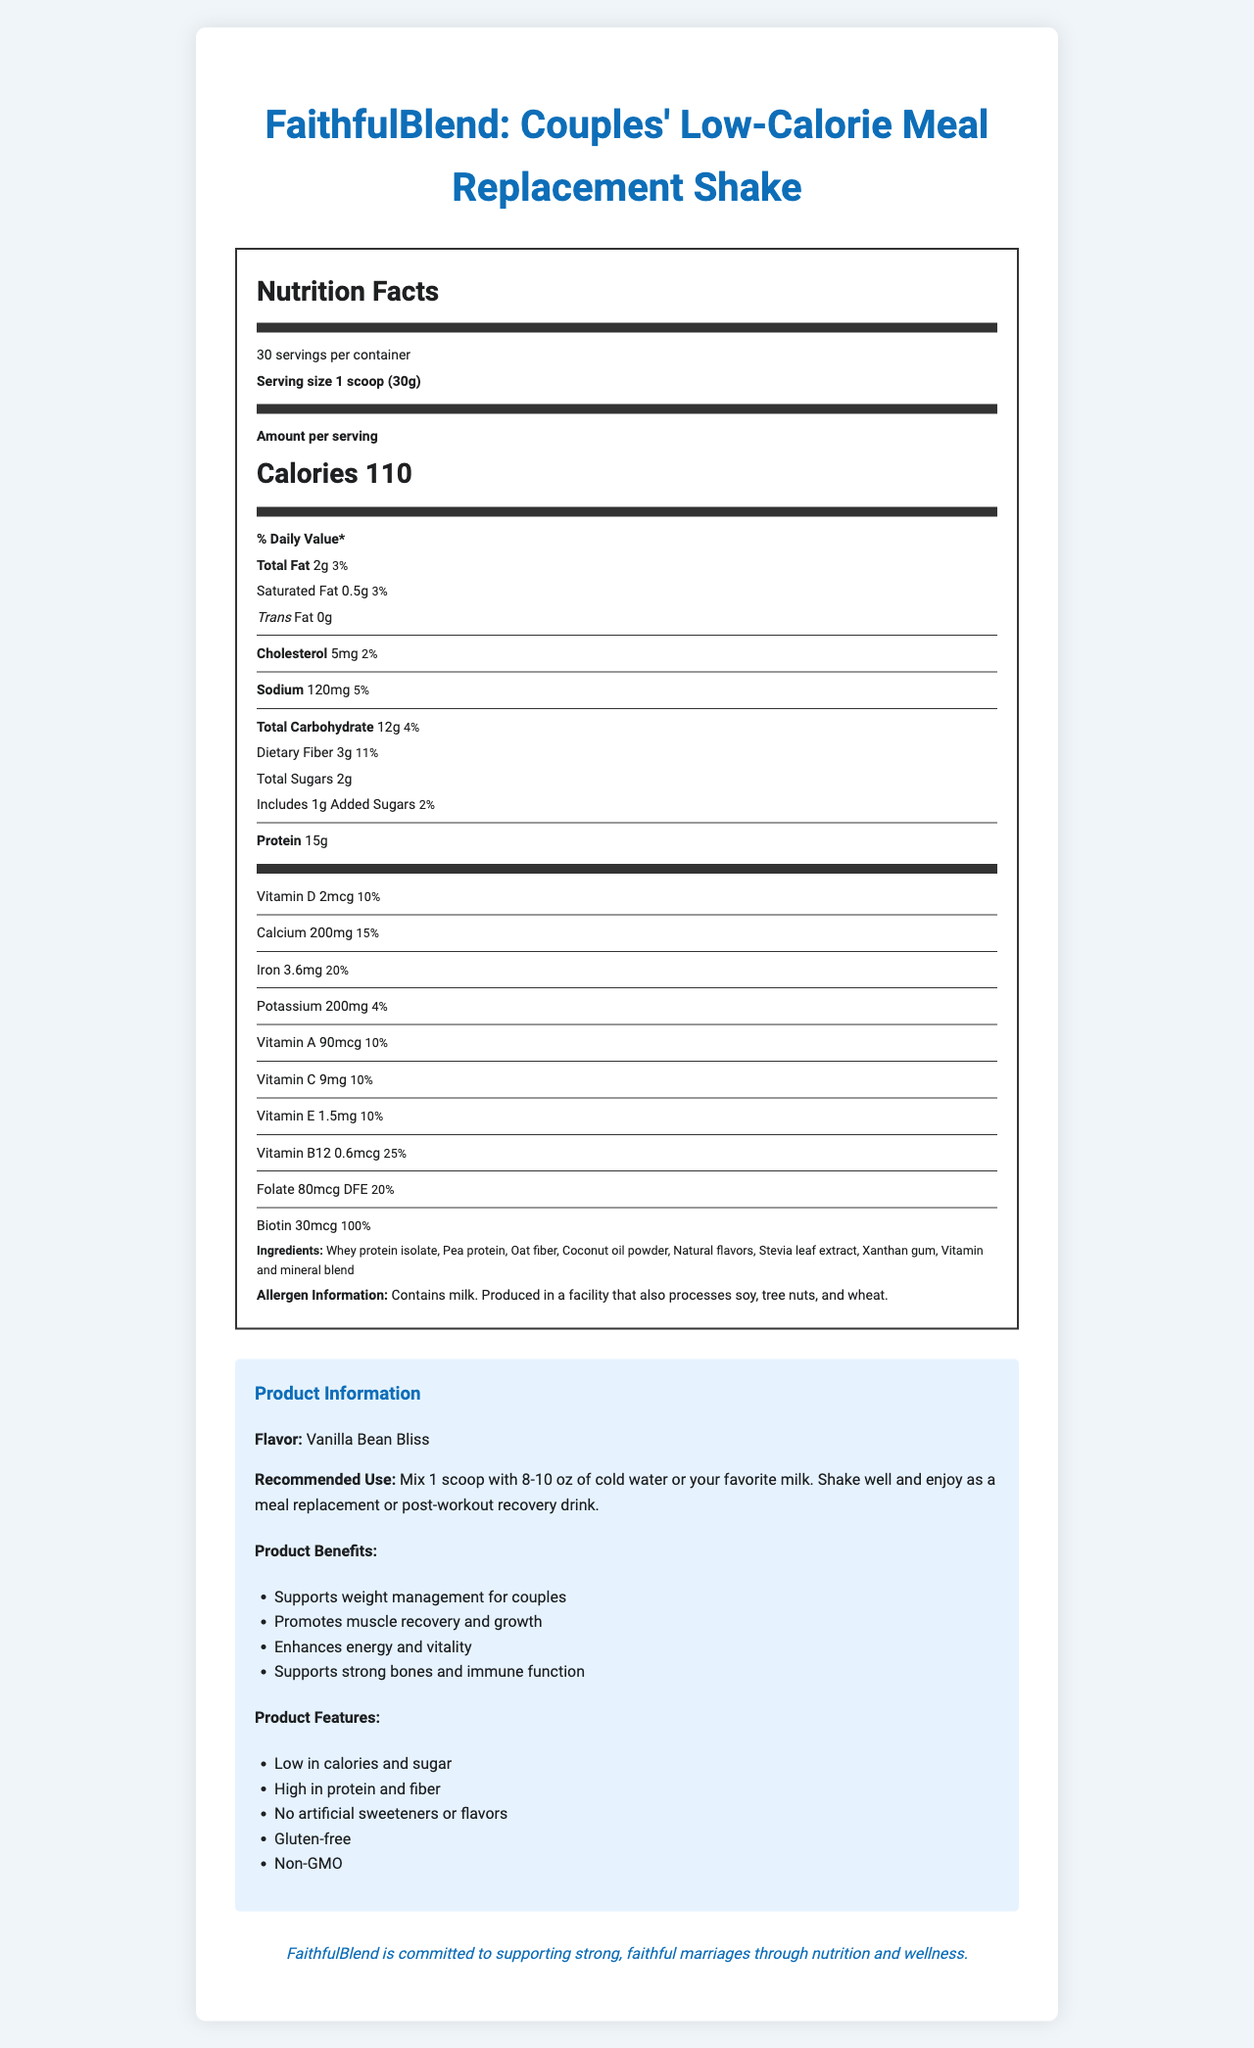what is the serving size for this meal replacement shake? The document states that the serving size is 1 scoop which weighs 30 grams.
Answer: 1 scoop (30g) how many servings are in one container? The document indicates that there are 30 servings per container.
Answer: 30 servings how many calories are in one serving of this shake? The calorie count per serving is listed as 110.
Answer: 110 calories what is the amount of protein in one serving? The amount of protein per serving is clearly stated to be 15 grams.
Answer: 15g which vitamin is most abundant in terms of daily value percent? Biotin has a daily value of 100% per serving, the highest among the listed vitamins and minerals.
Answer: Biotin you want to know the sodium content per serving. what is it? The document mentions that the sodium content per serving is 120mg.
Answer: 120mg does the shake contain any artificial sweeteners or flavors? The product features specifically state that there are no artificial sweeteners or flavors.
Answer: No what are the primary protein sources in this shake? The ingredients list includes Whey protein isolate and Pea protein, making them the primary sources of protein.
Answer: Whey protein isolate and Pea protein list one food allergen mentioned in the allergen information. The allergen information states that the product contains milk.
Answer: Milk what is the calorie count for the total fat per serving? A. 18 calories B. 27 calories C. 11 calories D. 22 calories Total fat is 2g per serving, and since fat has 9 calories per gram, it totals 18 calories (2g * 9 = 18).
Answer: B which of the following vitamins has a daily value of 10% per serving? I. Vitamin D II. Vitamin A III. Vitamin C IV. Vitamin E All listed vitamins (Vitamin D, A, C, and E) have a daily value of 10%.
Answer: I, II, III, IV is this product gluten-free? The product features clearly state that the shake is gluten-free.
Answer: Yes summarize the main benefits of using FaithfulBlend. The product benefits listed in the document include weight management, muscle recovery, energy and vitality enhancement, and support for bones and the immune system.
Answer: Supports weight management for couples, promotes muscle recovery and growth, enhances energy and vitality, supports strong bones and immune function how much dietary fiber does this shake provide? Each serving contains 3 grams of dietary fiber.
Answer: 3g describe the flavor of this meal replacement shake. The document describes the flavor as "Vanilla Bean Bliss."
Answer: Vanilla Bean Bliss how many grams of total carbohydrates are in one serving? The total carbohydrate per serving is noted as 12 grams.
Answer: 12g is there any information about how this product supports strong marriages? FaithfulBlend is committed to supporting strong, faithful marriages through nutrition and wellness.
Answer: Yes what is the ratio of added sugars to total sugars in one serving? The document mentions that 1g of the total 2g of sugars are added sugars.
Answer: 1g out of 2g list three main ingredients found in FaithfulBlend. The main ingredients include Whey protein isolate, Pea protein, and Oat fiber.
Answer: Whey protein isolate, Pea protein, Oat fiber can you identify the exact amount of Stevia leaf extract used in the shake? The document lists Stevia leaf extract as an ingredient but does not specify the exact amount used.
Answer: Cannot be determined 